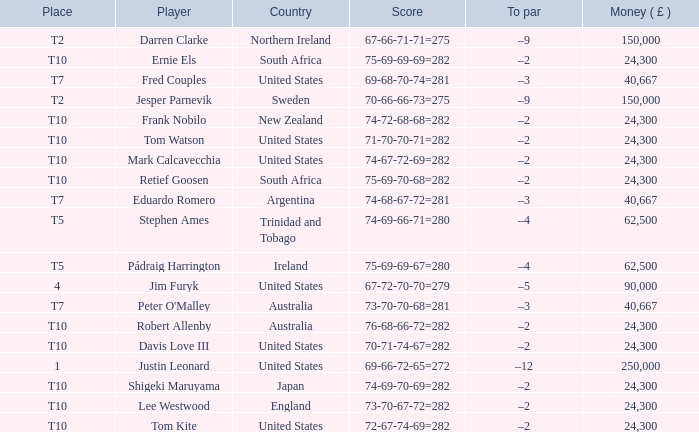How much money has been won by Stephen Ames? 62500.0. Parse the table in full. {'header': ['Place', 'Player', 'Country', 'Score', 'To par', 'Money ( £ )'], 'rows': [['T2', 'Darren Clarke', 'Northern Ireland', '67-66-71-71=275', '–9', '150,000'], ['T10', 'Ernie Els', 'South Africa', '75-69-69-69=282', '–2', '24,300'], ['T7', 'Fred Couples', 'United States', '69-68-70-74=281', '–3', '40,667'], ['T2', 'Jesper Parnevik', 'Sweden', '70-66-66-73=275', '–9', '150,000'], ['T10', 'Frank Nobilo', 'New Zealand', '74-72-68-68=282', '–2', '24,300'], ['T10', 'Tom Watson', 'United States', '71-70-70-71=282', '–2', '24,300'], ['T10', 'Mark Calcavecchia', 'United States', '74-67-72-69=282', '–2', '24,300'], ['T10', 'Retief Goosen', 'South Africa', '75-69-70-68=282', '–2', '24,300'], ['T7', 'Eduardo Romero', 'Argentina', '74-68-67-72=281', '–3', '40,667'], ['T5', 'Stephen Ames', 'Trinidad and Tobago', '74-69-66-71=280', '–4', '62,500'], ['T5', 'Pádraig Harrington', 'Ireland', '75-69-69-67=280', '–4', '62,500'], ['4', 'Jim Furyk', 'United States', '67-72-70-70=279', '–5', '90,000'], ['T7', "Peter O'Malley", 'Australia', '73-70-70-68=281', '–3', '40,667'], ['T10', 'Robert Allenby', 'Australia', '76-68-66-72=282', '–2', '24,300'], ['T10', 'Davis Love III', 'United States', '70-71-74-67=282', '–2', '24,300'], ['1', 'Justin Leonard', 'United States', '69-66-72-65=272', '–12', '250,000'], ['T10', 'Shigeki Maruyama', 'Japan', '74-69-70-69=282', '–2', '24,300'], ['T10', 'Lee Westwood', 'England', '73-70-67-72=282', '–2', '24,300'], ['T10', 'Tom Kite', 'United States', '72-67-74-69=282', '–2', '24,300']]} 